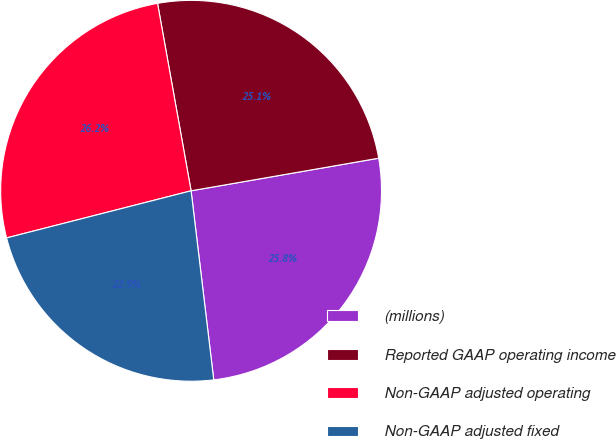<chart> <loc_0><loc_0><loc_500><loc_500><pie_chart><fcel>(millions)<fcel>Reported GAAP operating income<fcel>Non-GAAP adjusted operating<fcel>Non-GAAP adjusted fixed<nl><fcel>25.84%<fcel>25.08%<fcel>26.16%<fcel>22.92%<nl></chart> 